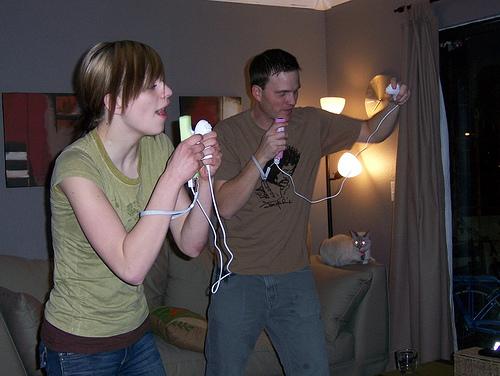What are they playing?
Keep it brief. Wii. What is she wearing on her wrist?
Be succinct. Wii controller. Is there a reflection in the cat?
Quick response, please. Yes. Is he serving her wine?
Quick response, please. No. What is the girl using?
Concise answer only. Wii remote. What kind of game are the children playing?
Give a very brief answer. Wii. What time does the clock read?
Answer briefly. No clock. Is this lady old or young?
Write a very short answer. Young. Is the man wearing glasses?
Short answer required. No. Are the lights on or off?
Quick response, please. On. Which woman is looking at her phone?
Write a very short answer. None. Does the woman have on a ring?
Quick response, please. No. What is the woman holding by her ear?
Quick response, please. Controller. Does it seem as if the action being watched is rather high up?
Write a very short answer. No. 